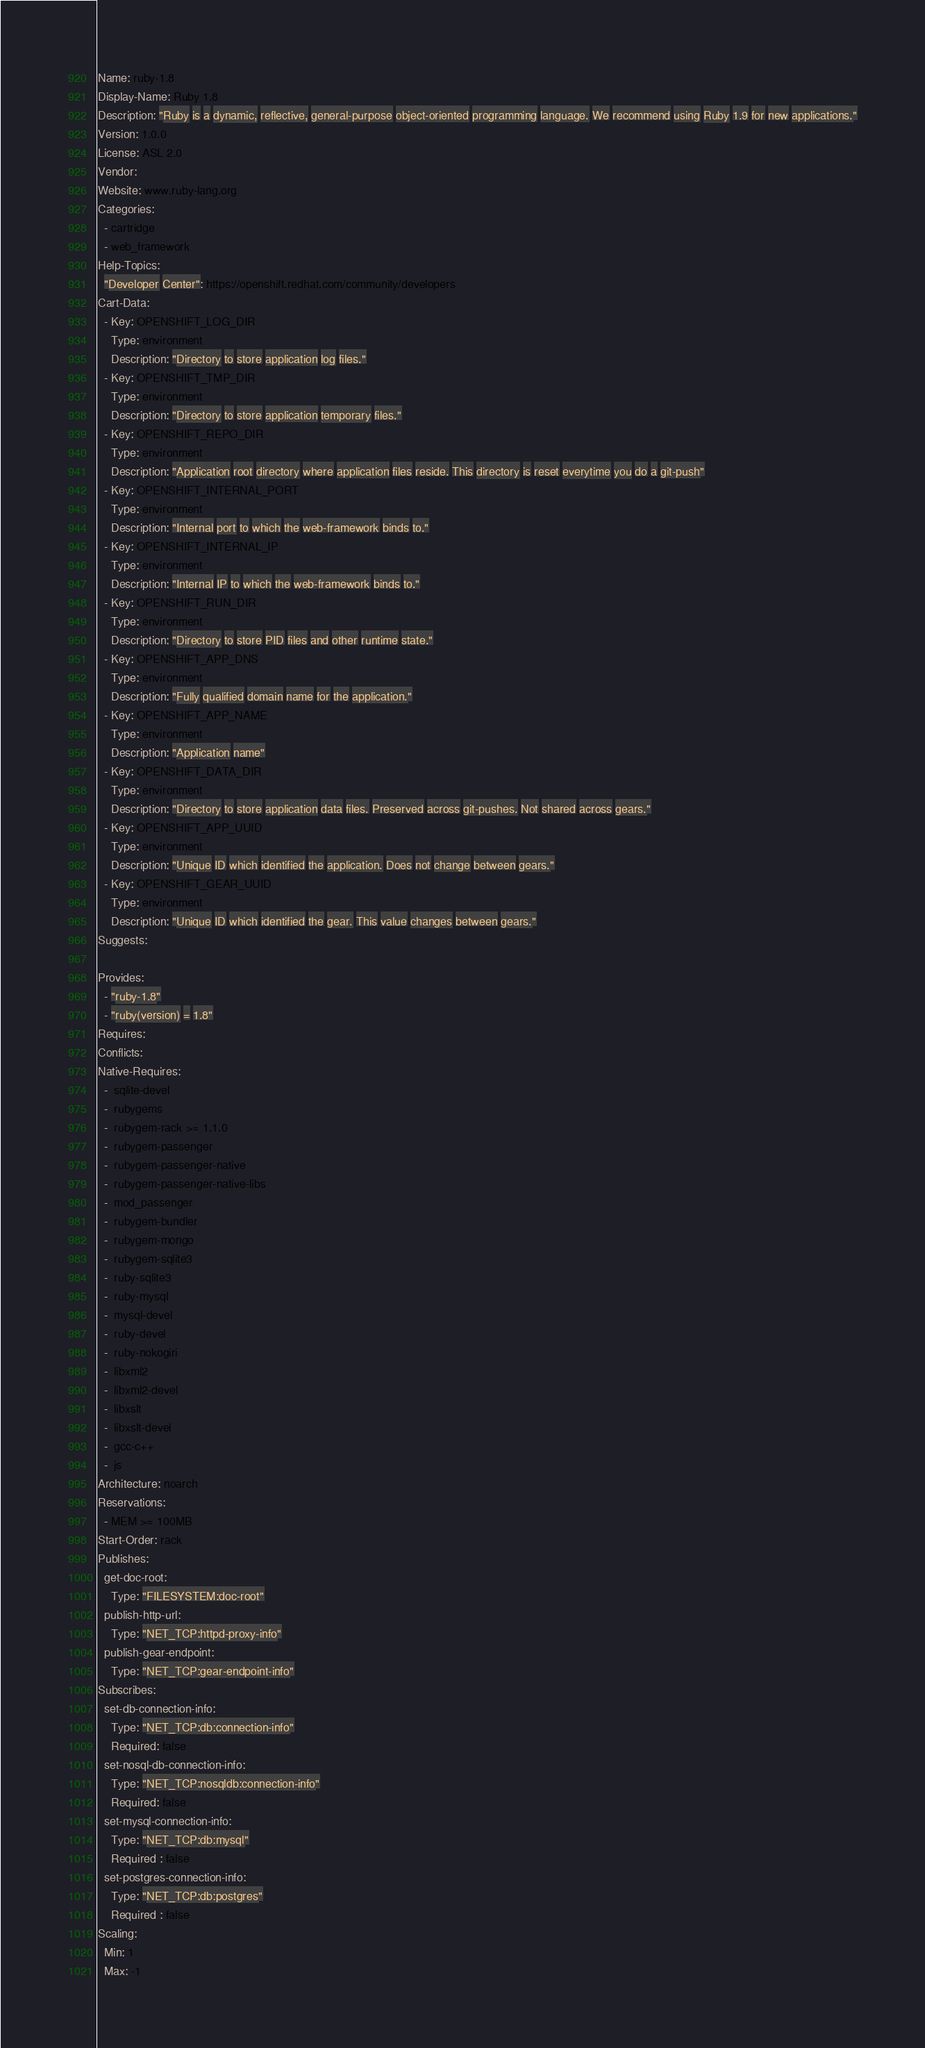<code> <loc_0><loc_0><loc_500><loc_500><_YAML_>Name: ruby-1.8
Display-Name: Ruby 1.8
Description: "Ruby is a dynamic, reflective, general-purpose object-oriented programming language. We recommend using Ruby 1.9 for new applications."
Version: 1.0.0
License: ASL 2.0
Vendor:  
Website: www.ruby-lang.org
Categories:
  - cartridge
  - web_framework
Help-Topics:
  "Developer Center": https://openshift.redhat.com/community/developers
Cart-Data:
  - Key: OPENSHIFT_LOG_DIR
    Type: environment
    Description: "Directory to store application log files."
  - Key: OPENSHIFT_TMP_DIR
    Type: environment
    Description: "Directory to store application temporary files."
  - Key: OPENSHIFT_REPO_DIR
    Type: environment
    Description: "Application root directory where application files reside. This directory is reset everytime you do a git-push"
  - Key: OPENSHIFT_INTERNAL_PORT
    Type: environment
    Description: "Internal port to which the web-framework binds to."
  - Key: OPENSHIFT_INTERNAL_IP
    Type: environment
    Description: "Internal IP to which the web-framework binds to."
  - Key: OPENSHIFT_RUN_DIR
    Type: environment
    Description: "Directory to store PID files and other runtime state."
  - Key: OPENSHIFT_APP_DNS
    Type: environment
    Description: "Fully qualified domain name for the application."
  - Key: OPENSHIFT_APP_NAME
    Type: environment
    Description: "Application name"
  - Key: OPENSHIFT_DATA_DIR
    Type: environment
    Description: "Directory to store application data files. Preserved across git-pushes. Not shared across gears."
  - Key: OPENSHIFT_APP_UUID
    Type: environment
    Description: "Unique ID which identified the application. Does not change between gears."
  - Key: OPENSHIFT_GEAR_UUID
    Type: environment
    Description: "Unique ID which identified the gear. This value changes between gears."
Suggests:
    
Provides:
  - "ruby-1.8"
  - "ruby(version) = 1.8"
Requires:
Conflicts:
Native-Requires:
  -  sqlite-devel
  -  rubygems
  -  rubygem-rack >= 1.1.0
  -  rubygem-passenger
  -  rubygem-passenger-native
  -  rubygem-passenger-native-libs
  -  mod_passenger
  -  rubygem-bundler
  -  rubygem-mongo
  -  rubygem-sqlite3
  -  ruby-sqlite3
  -  ruby-mysql
  -  mysql-devel
  -  ruby-devel
  -  ruby-nokogiri
  -  libxml2
  -  libxml2-devel
  -  libxslt
  -  libxslt-devel
  -  gcc-c++
  -  js
Architecture: noarch
Reservations:
  - MEM >= 100MB
Start-Order: rack
Publishes:
  get-doc-root:
    Type: "FILESYSTEM:doc-root"
  publish-http-url:
    Type: "NET_TCP:httpd-proxy-info"
  publish-gear-endpoint:
    Type: "NET_TCP:gear-endpoint-info"
Subscribes:
  set-db-connection-info:
    Type: "NET_TCP:db:connection-info"
    Required: false
  set-nosql-db-connection-info:
    Type: "NET_TCP:nosqldb:connection-info"
    Required: false
  set-mysql-connection-info:
    Type: "NET_TCP:db:mysql"
    Required : false
  set-postgres-connection-info:
    Type: "NET_TCP:db:postgres"
    Required : false
Scaling:
  Min: 1
  Max: -1
</code> 